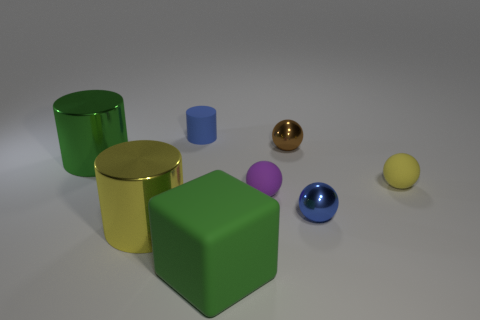There is a thing that is the same color as the cube; what is its shape?
Offer a very short reply. Cylinder. There is a blue object that is in front of the small yellow matte sphere; how many big shiny objects are behind it?
Provide a succinct answer. 1. What is the color of the matte cylinder that is the same size as the yellow ball?
Provide a succinct answer. Blue. What is the material of the yellow thing right of the large cube?
Make the answer very short. Rubber. There is a big thing that is both on the left side of the small cylinder and in front of the big green metal cylinder; what material is it made of?
Make the answer very short. Metal. Do the green thing that is left of the green matte thing and the small purple ball have the same size?
Your answer should be compact. No. What shape is the small blue metallic thing?
Give a very brief answer. Sphere. How many other purple rubber objects are the same shape as the tiny purple matte object?
Provide a short and direct response. 0. How many objects are both to the right of the purple thing and on the left side of the small yellow rubber sphere?
Offer a terse response. 2. The matte cube is what color?
Make the answer very short. Green. 